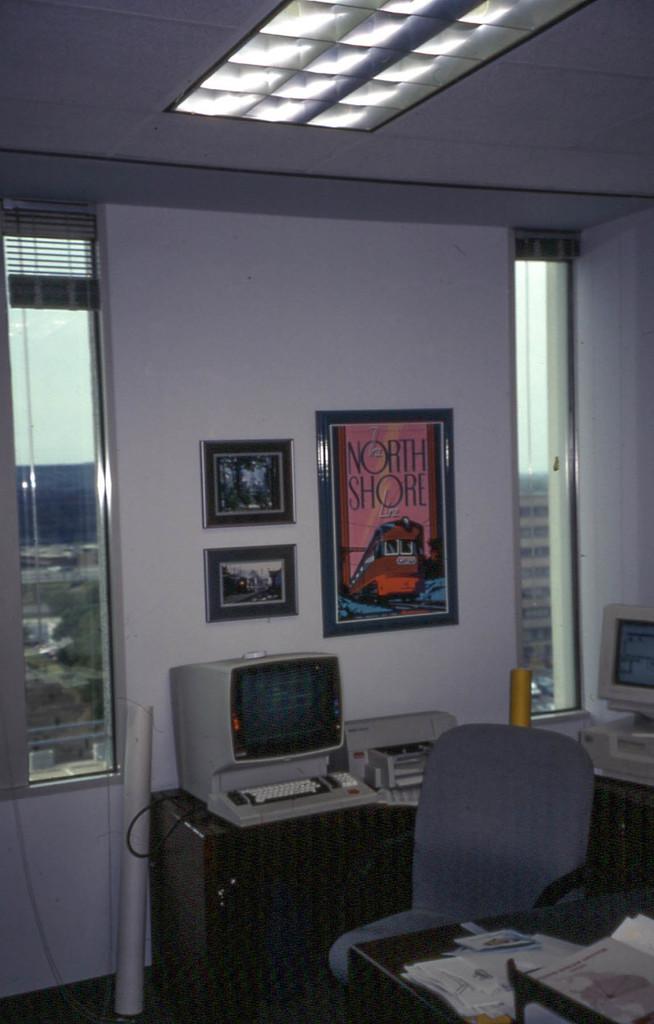What location is written on the pink poster?
Offer a very short reply. North shore. 